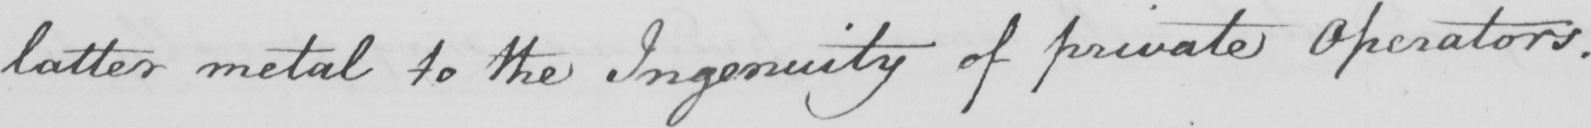What does this handwritten line say? latter metal to the Ingenuity of private Operators . 